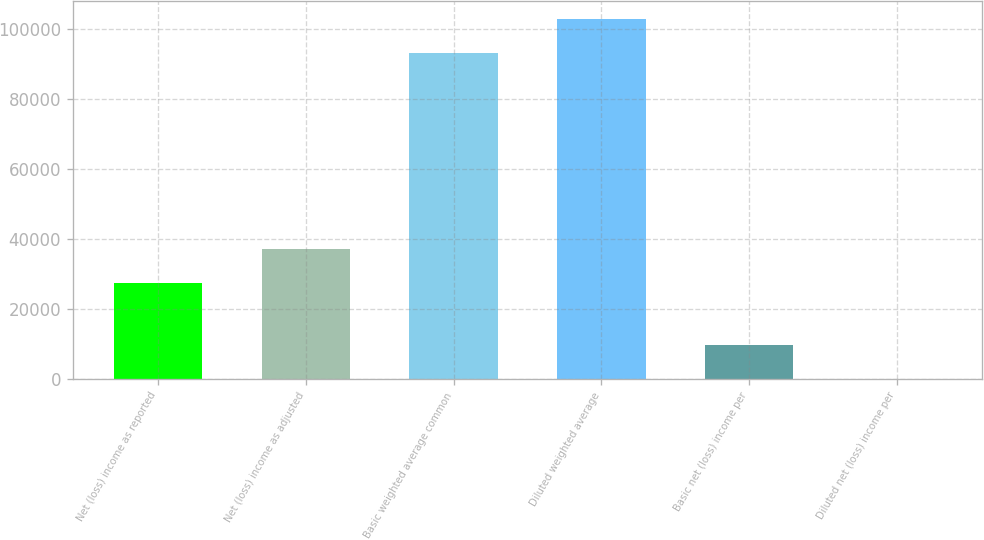Convert chart. <chart><loc_0><loc_0><loc_500><loc_500><bar_chart><fcel>Net (loss) income as reported<fcel>Net (loss) income as adjusted<fcel>Basic weighted average common<fcel>Diluted weighted average<fcel>Basic net (loss) income per<fcel>Diluted net (loss) income per<nl><fcel>27423<fcel>37147<fcel>93025<fcel>102749<fcel>9724.25<fcel>0.28<nl></chart> 